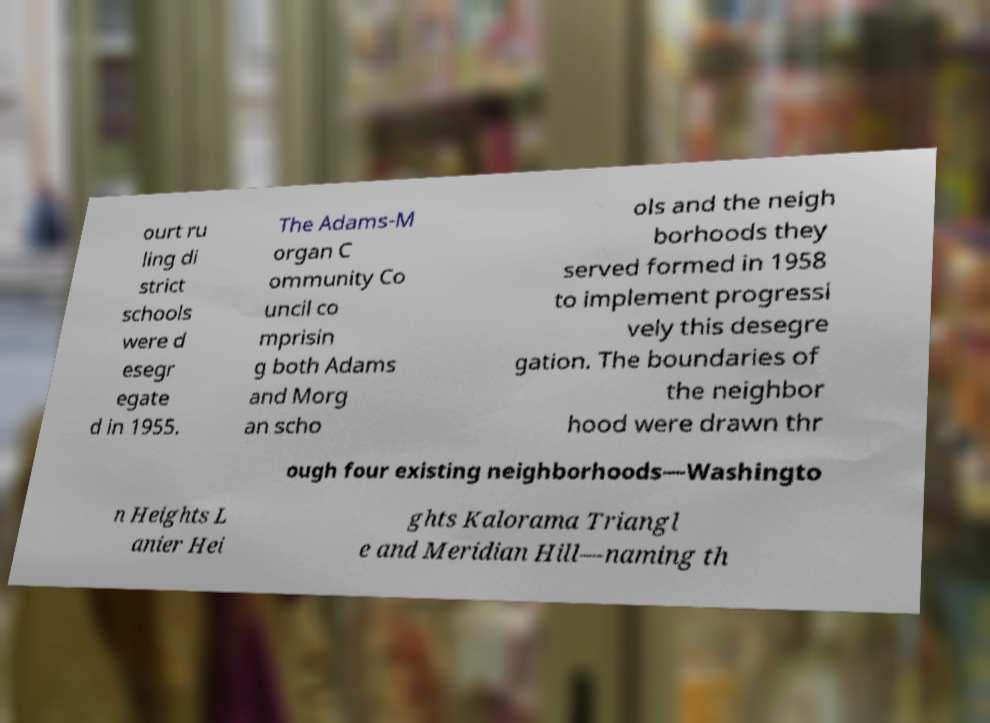For documentation purposes, I need the text within this image transcribed. Could you provide that? ourt ru ling di strict schools were d esegr egate d in 1955. The Adams-M organ C ommunity Co uncil co mprisin g both Adams and Morg an scho ols and the neigh borhoods they served formed in 1958 to implement progressi vely this desegre gation. The boundaries of the neighbor hood were drawn thr ough four existing neighborhoods—Washingto n Heights L anier Hei ghts Kalorama Triangl e and Meridian Hill—naming th 